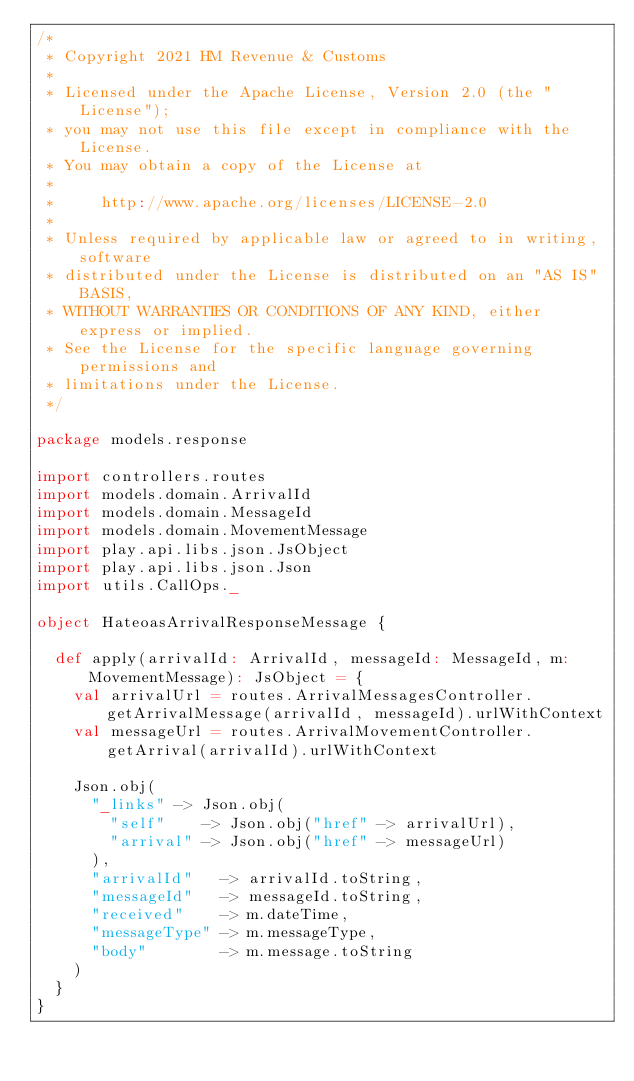Convert code to text. <code><loc_0><loc_0><loc_500><loc_500><_Scala_>/*
 * Copyright 2021 HM Revenue & Customs
 *
 * Licensed under the Apache License, Version 2.0 (the "License");
 * you may not use this file except in compliance with the License.
 * You may obtain a copy of the License at
 *
 *     http://www.apache.org/licenses/LICENSE-2.0
 *
 * Unless required by applicable law or agreed to in writing, software
 * distributed under the License is distributed on an "AS IS" BASIS,
 * WITHOUT WARRANTIES OR CONDITIONS OF ANY KIND, either express or implied.
 * See the License for the specific language governing permissions and
 * limitations under the License.
 */

package models.response

import controllers.routes
import models.domain.ArrivalId
import models.domain.MessageId
import models.domain.MovementMessage
import play.api.libs.json.JsObject
import play.api.libs.json.Json
import utils.CallOps._

object HateoasArrivalResponseMessage {

  def apply(arrivalId: ArrivalId, messageId: MessageId, m: MovementMessage): JsObject = {
    val arrivalUrl = routes.ArrivalMessagesController.getArrivalMessage(arrivalId, messageId).urlWithContext
    val messageUrl = routes.ArrivalMovementController.getArrival(arrivalId).urlWithContext

    Json.obj(
      "_links" -> Json.obj(
        "self"    -> Json.obj("href" -> arrivalUrl),
        "arrival" -> Json.obj("href" -> messageUrl)
      ),
      "arrivalId"   -> arrivalId.toString,
      "messageId"   -> messageId.toString,
      "received"    -> m.dateTime,
      "messageType" -> m.messageType,
      "body"        -> m.message.toString
    )
  }
}
</code> 